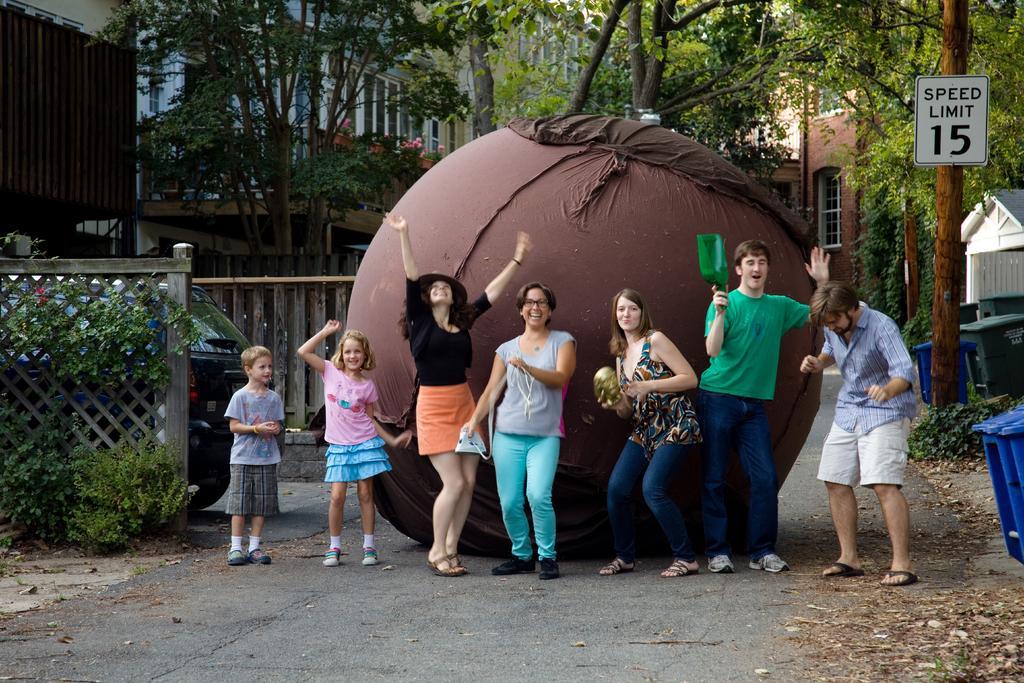In one or two sentences, can you explain what this image depicts? In this image we can see a group of people standing on the road. In that three people are holding some objects. We can also see a big ball on the ground, a car placed aside, the wooden fence, some plants, dustbins, a signboard on the bark of a tree, a group of trees and some buildings. 